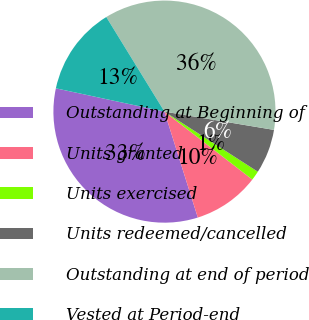<chart> <loc_0><loc_0><loc_500><loc_500><pie_chart><fcel>Outstanding at Beginning of<fcel>Units granted<fcel>Units exercised<fcel>Units redeemed/cancelled<fcel>Outstanding at end of period<fcel>Vested at Period-end<nl><fcel>33.22%<fcel>9.67%<fcel>1.37%<fcel>6.47%<fcel>36.41%<fcel>12.86%<nl></chart> 